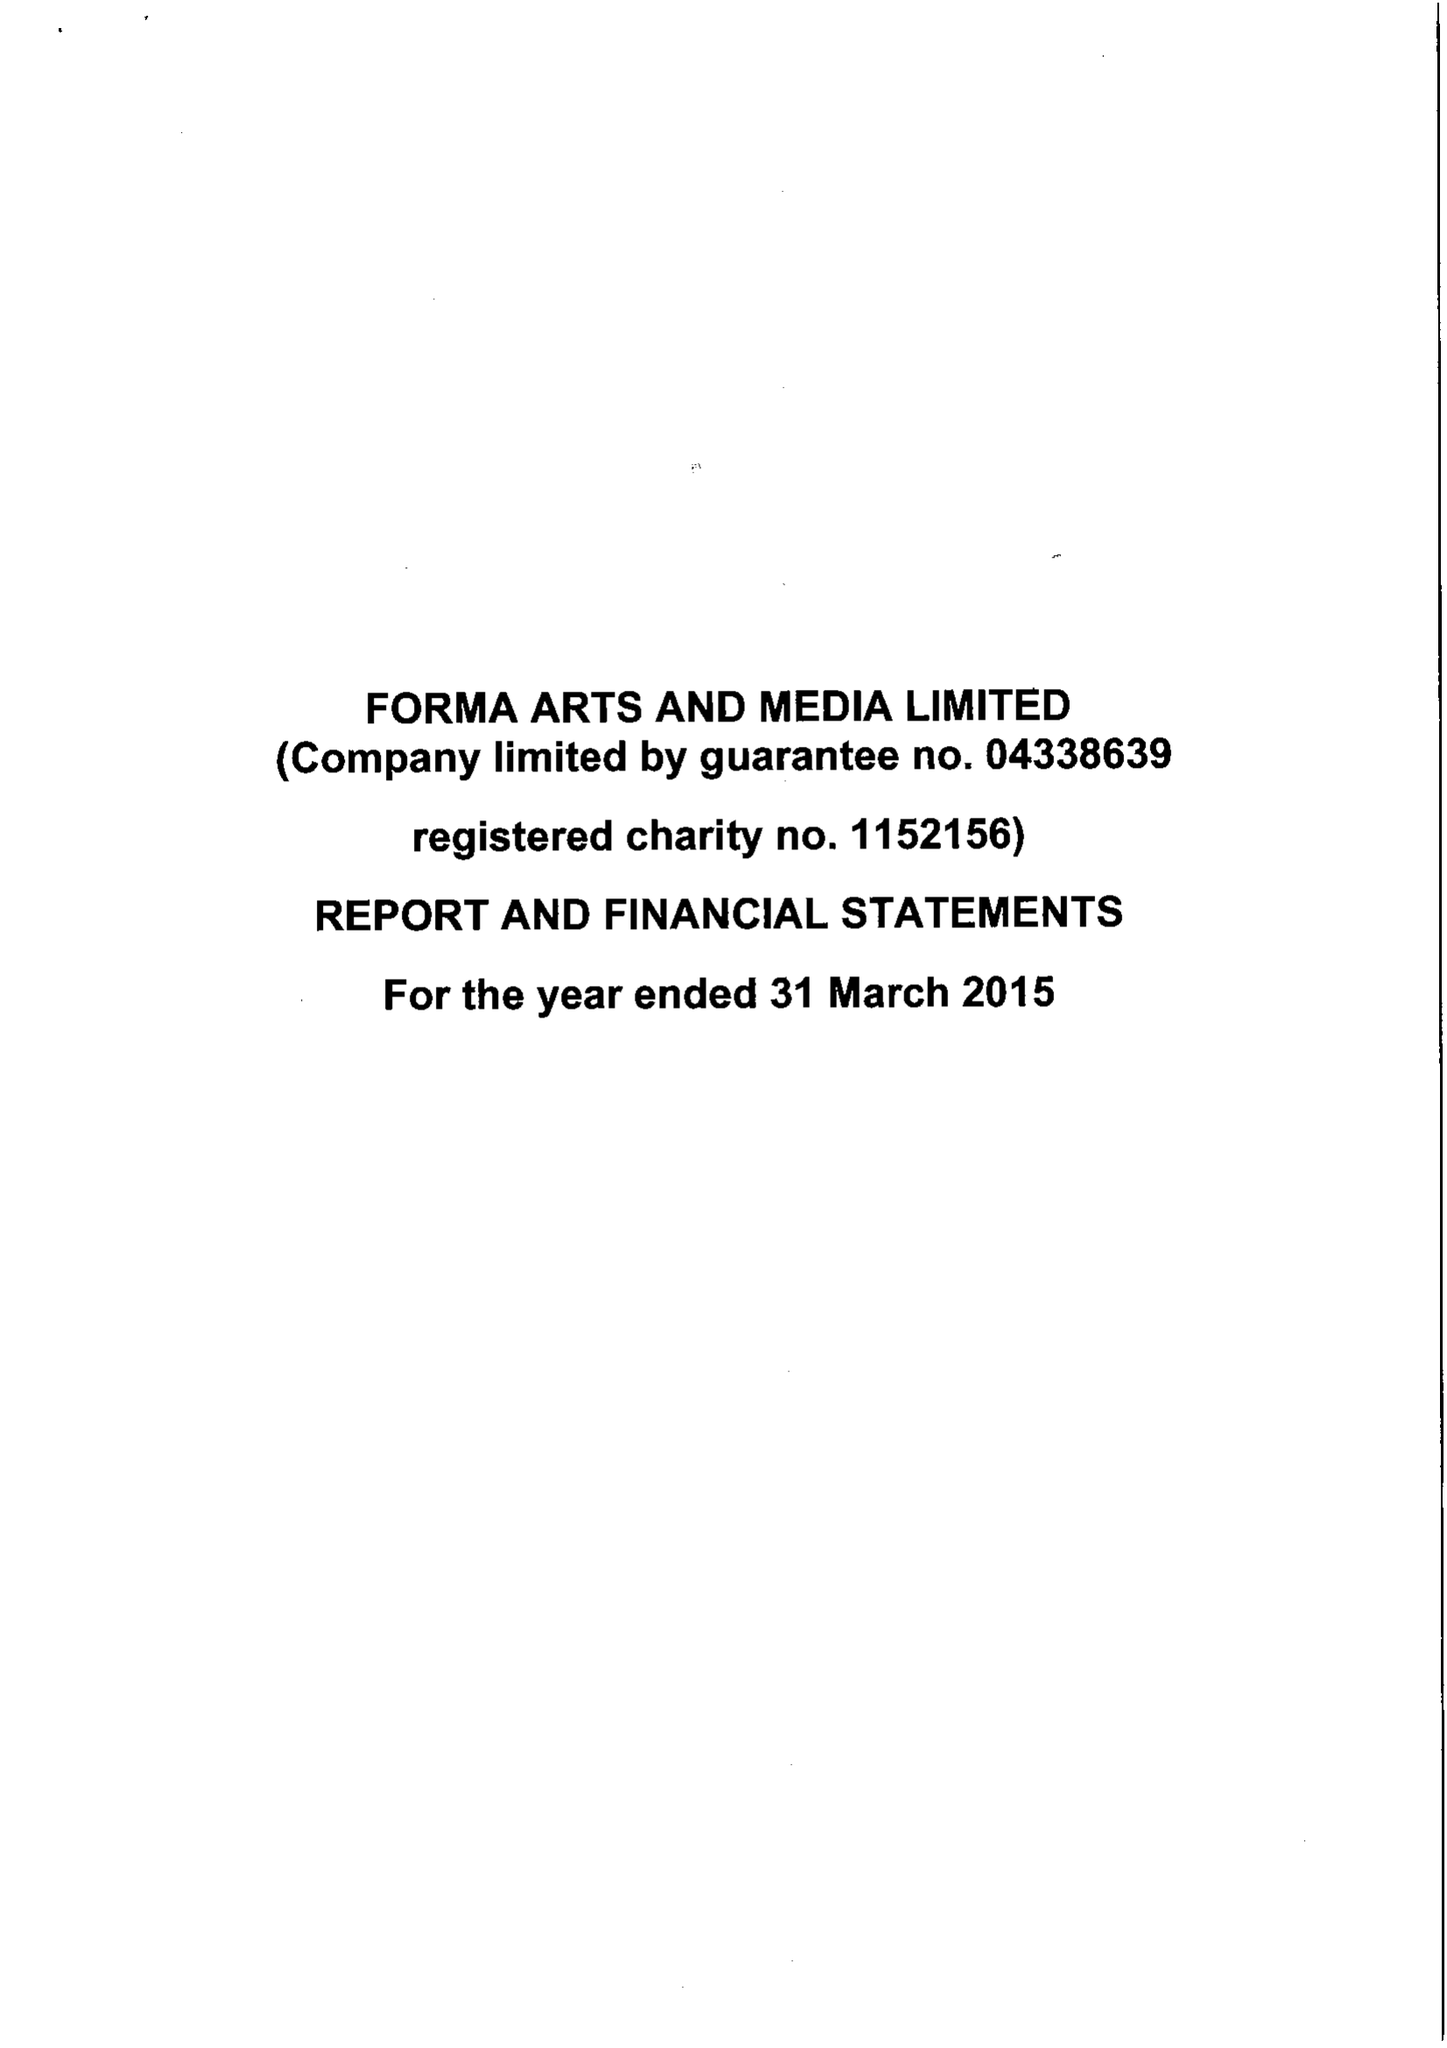What is the value for the spending_annually_in_british_pounds?
Answer the question using a single word or phrase. 688315.00 